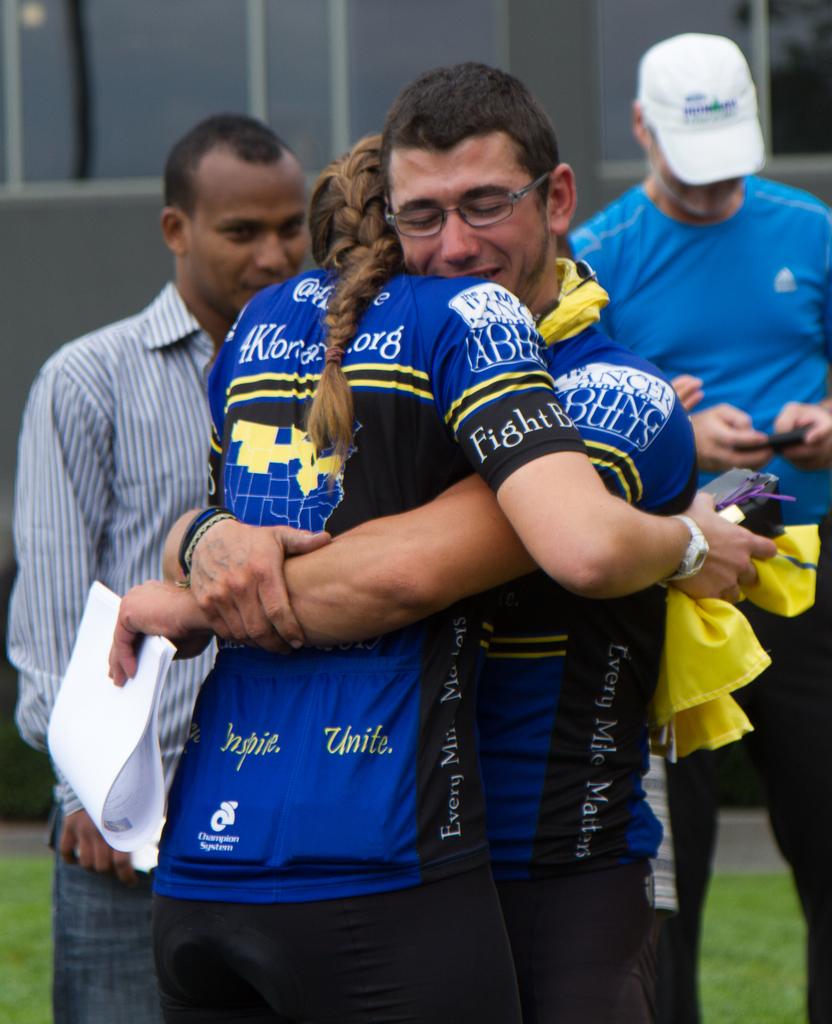What color is the word "unite" on her jersey?
Offer a very short reply. Yellow. 